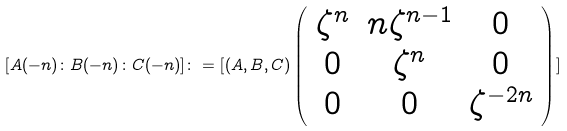<formula> <loc_0><loc_0><loc_500><loc_500>[ A ( - n ) \colon B ( - n ) \colon C ( - n ) ] \colon = [ ( A , B , C ) \left ( \begin{array} { c c c } \zeta ^ { n } & n \zeta ^ { n - 1 } & 0 \\ 0 & \zeta ^ { n } & 0 \\ 0 & 0 & \zeta ^ { - 2 n } \end{array} \right ) ]</formula> 